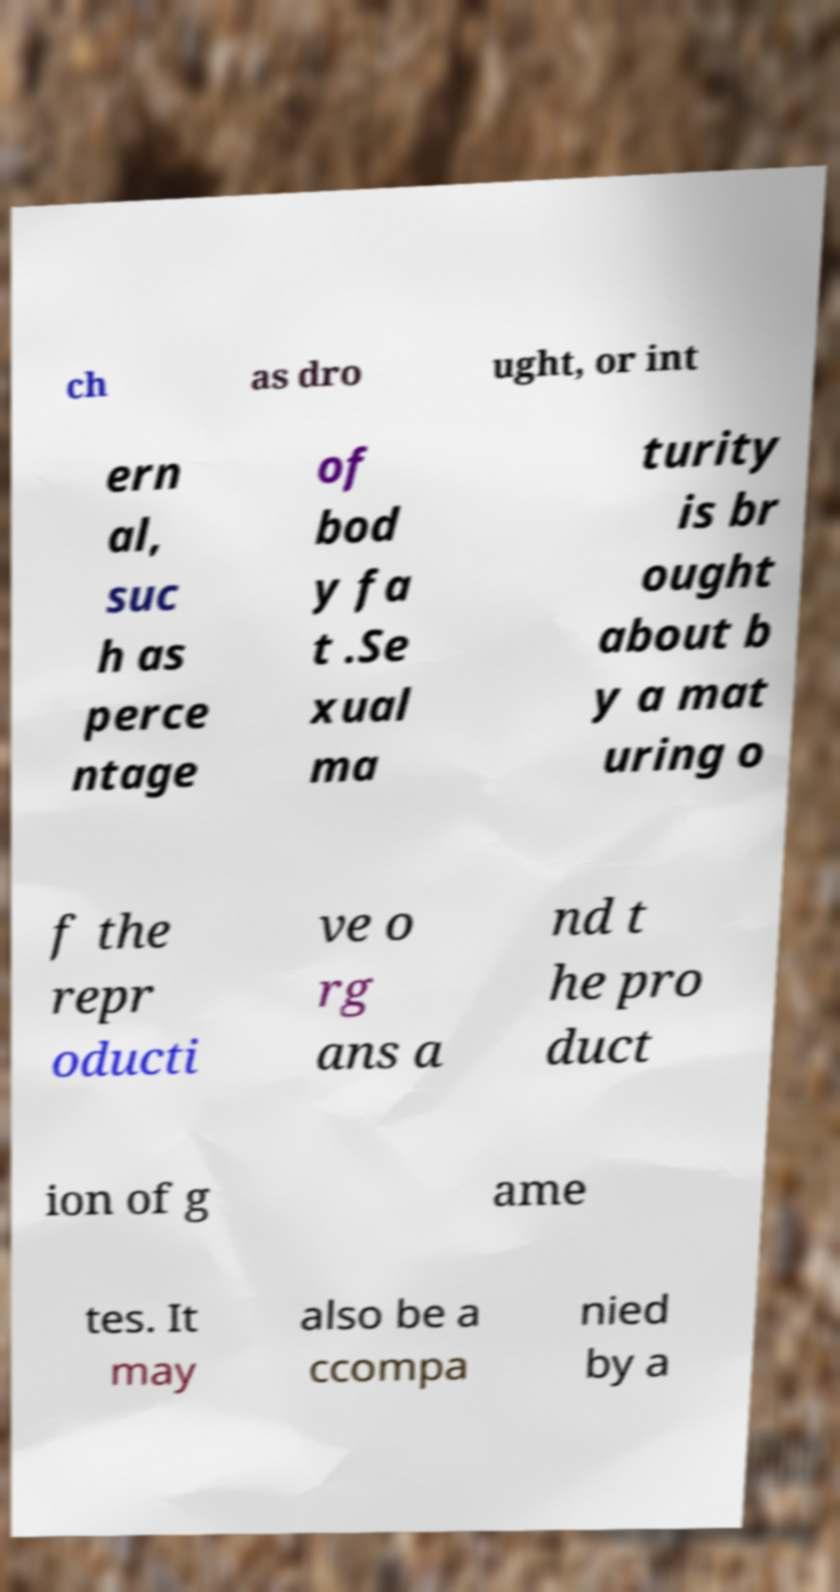Can you accurately transcribe the text from the provided image for me? ch as dro ught, or int ern al, suc h as perce ntage of bod y fa t .Se xual ma turity is br ought about b y a mat uring o f the repr oducti ve o rg ans a nd t he pro duct ion of g ame tes. It may also be a ccompa nied by a 